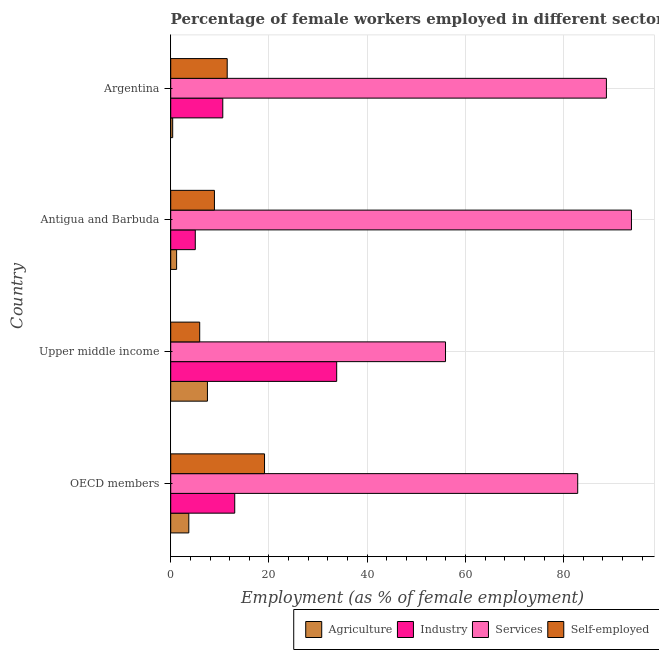How many different coloured bars are there?
Your answer should be compact. 4. How many bars are there on the 4th tick from the top?
Provide a succinct answer. 4. What is the label of the 1st group of bars from the top?
Your response must be concise. Argentina. In how many cases, is the number of bars for a given country not equal to the number of legend labels?
Your response must be concise. 0. What is the percentage of female workers in agriculture in OECD members?
Give a very brief answer. 3.68. Across all countries, what is the maximum percentage of self employed female workers?
Your response must be concise. 19.1. Across all countries, what is the minimum percentage of female workers in agriculture?
Offer a very short reply. 0.4. In which country was the percentage of self employed female workers minimum?
Make the answer very short. Upper middle income. What is the total percentage of female workers in agriculture in the graph?
Ensure brevity in your answer.  12.76. What is the difference between the percentage of female workers in agriculture in Argentina and that in OECD members?
Provide a succinct answer. -3.28. What is the difference between the percentage of self employed female workers in OECD members and the percentage of female workers in industry in Upper middle income?
Your answer should be very brief. -14.69. What is the average percentage of female workers in industry per country?
Provide a short and direct response. 15.61. What is the difference between the percentage of self employed female workers and percentage of female workers in services in Antigua and Barbuda?
Make the answer very short. -84.9. What is the ratio of the percentage of self employed female workers in Argentina to that in Upper middle income?
Offer a terse response. 1.95. Is the percentage of female workers in agriculture in Antigua and Barbuda less than that in Upper middle income?
Provide a short and direct response. Yes. Is the difference between the percentage of female workers in agriculture in Argentina and Upper middle income greater than the difference between the percentage of female workers in industry in Argentina and Upper middle income?
Make the answer very short. Yes. What is the difference between the highest and the second highest percentage of female workers in industry?
Provide a succinct answer. 20.75. What is the difference between the highest and the lowest percentage of female workers in agriculture?
Provide a succinct answer. 7.07. Is the sum of the percentage of self employed female workers in Argentina and Upper middle income greater than the maximum percentage of female workers in agriculture across all countries?
Offer a terse response. Yes. What does the 3rd bar from the top in Upper middle income represents?
Make the answer very short. Industry. What does the 1st bar from the bottom in Upper middle income represents?
Your response must be concise. Agriculture. Are all the bars in the graph horizontal?
Your response must be concise. Yes. How many countries are there in the graph?
Your response must be concise. 4. What is the difference between two consecutive major ticks on the X-axis?
Make the answer very short. 20. Does the graph contain any zero values?
Keep it short and to the point. No. Where does the legend appear in the graph?
Your answer should be compact. Bottom right. What is the title of the graph?
Offer a terse response. Percentage of female workers employed in different sectors of an economy in 2007. Does "Regional development banks" appear as one of the legend labels in the graph?
Make the answer very short. No. What is the label or title of the X-axis?
Keep it short and to the point. Employment (as % of female employment). What is the label or title of the Y-axis?
Your answer should be very brief. Country. What is the Employment (as % of female employment) in Agriculture in OECD members?
Ensure brevity in your answer.  3.68. What is the Employment (as % of female employment) of Industry in OECD members?
Provide a succinct answer. 13.03. What is the Employment (as % of female employment) in Services in OECD members?
Your answer should be very brief. 82.86. What is the Employment (as % of female employment) of Self-employed in OECD members?
Provide a succinct answer. 19.1. What is the Employment (as % of female employment) of Agriculture in Upper middle income?
Provide a succinct answer. 7.47. What is the Employment (as % of female employment) in Industry in Upper middle income?
Keep it short and to the point. 33.79. What is the Employment (as % of female employment) of Services in Upper middle income?
Provide a succinct answer. 55.94. What is the Employment (as % of female employment) of Self-employed in Upper middle income?
Provide a succinct answer. 5.9. What is the Employment (as % of female employment) of Agriculture in Antigua and Barbuda?
Provide a succinct answer. 1.2. What is the Employment (as % of female employment) in Services in Antigua and Barbuda?
Provide a short and direct response. 93.8. What is the Employment (as % of female employment) of Self-employed in Antigua and Barbuda?
Provide a short and direct response. 8.9. What is the Employment (as % of female employment) of Agriculture in Argentina?
Your answer should be very brief. 0.4. What is the Employment (as % of female employment) in Industry in Argentina?
Offer a very short reply. 10.6. What is the Employment (as % of female employment) in Services in Argentina?
Your answer should be very brief. 88.7. Across all countries, what is the maximum Employment (as % of female employment) in Agriculture?
Offer a very short reply. 7.47. Across all countries, what is the maximum Employment (as % of female employment) of Industry?
Your answer should be very brief. 33.79. Across all countries, what is the maximum Employment (as % of female employment) in Services?
Offer a terse response. 93.8. Across all countries, what is the maximum Employment (as % of female employment) of Self-employed?
Your answer should be compact. 19.1. Across all countries, what is the minimum Employment (as % of female employment) in Agriculture?
Your answer should be very brief. 0.4. Across all countries, what is the minimum Employment (as % of female employment) in Services?
Provide a succinct answer. 55.94. Across all countries, what is the minimum Employment (as % of female employment) in Self-employed?
Your answer should be very brief. 5.9. What is the total Employment (as % of female employment) in Agriculture in the graph?
Your response must be concise. 12.76. What is the total Employment (as % of female employment) of Industry in the graph?
Your answer should be compact. 62.42. What is the total Employment (as % of female employment) of Services in the graph?
Your answer should be compact. 321.3. What is the total Employment (as % of female employment) of Self-employed in the graph?
Keep it short and to the point. 45.4. What is the difference between the Employment (as % of female employment) in Agriculture in OECD members and that in Upper middle income?
Make the answer very short. -3.79. What is the difference between the Employment (as % of female employment) of Industry in OECD members and that in Upper middle income?
Make the answer very short. -20.75. What is the difference between the Employment (as % of female employment) of Services in OECD members and that in Upper middle income?
Your answer should be compact. 26.91. What is the difference between the Employment (as % of female employment) of Self-employed in OECD members and that in Upper middle income?
Provide a succinct answer. 13.2. What is the difference between the Employment (as % of female employment) of Agriculture in OECD members and that in Antigua and Barbuda?
Offer a very short reply. 2.48. What is the difference between the Employment (as % of female employment) of Industry in OECD members and that in Antigua and Barbuda?
Offer a terse response. 8.03. What is the difference between the Employment (as % of female employment) of Services in OECD members and that in Antigua and Barbuda?
Your answer should be compact. -10.94. What is the difference between the Employment (as % of female employment) of Agriculture in OECD members and that in Argentina?
Provide a short and direct response. 3.28. What is the difference between the Employment (as % of female employment) in Industry in OECD members and that in Argentina?
Your response must be concise. 2.43. What is the difference between the Employment (as % of female employment) of Services in OECD members and that in Argentina?
Your answer should be very brief. -5.84. What is the difference between the Employment (as % of female employment) in Self-employed in OECD members and that in Argentina?
Make the answer very short. 7.6. What is the difference between the Employment (as % of female employment) in Agriculture in Upper middle income and that in Antigua and Barbuda?
Offer a terse response. 6.27. What is the difference between the Employment (as % of female employment) of Industry in Upper middle income and that in Antigua and Barbuda?
Your answer should be compact. 28.79. What is the difference between the Employment (as % of female employment) in Services in Upper middle income and that in Antigua and Barbuda?
Provide a short and direct response. -37.86. What is the difference between the Employment (as % of female employment) in Agriculture in Upper middle income and that in Argentina?
Provide a succinct answer. 7.07. What is the difference between the Employment (as % of female employment) in Industry in Upper middle income and that in Argentina?
Offer a terse response. 23.19. What is the difference between the Employment (as % of female employment) of Services in Upper middle income and that in Argentina?
Offer a very short reply. -32.76. What is the difference between the Employment (as % of female employment) of Agriculture in OECD members and the Employment (as % of female employment) of Industry in Upper middle income?
Keep it short and to the point. -30.11. What is the difference between the Employment (as % of female employment) of Agriculture in OECD members and the Employment (as % of female employment) of Services in Upper middle income?
Your response must be concise. -52.26. What is the difference between the Employment (as % of female employment) of Agriculture in OECD members and the Employment (as % of female employment) of Self-employed in Upper middle income?
Your response must be concise. -2.22. What is the difference between the Employment (as % of female employment) of Industry in OECD members and the Employment (as % of female employment) of Services in Upper middle income?
Provide a short and direct response. -42.91. What is the difference between the Employment (as % of female employment) in Industry in OECD members and the Employment (as % of female employment) in Self-employed in Upper middle income?
Your answer should be compact. 7.13. What is the difference between the Employment (as % of female employment) of Services in OECD members and the Employment (as % of female employment) of Self-employed in Upper middle income?
Provide a short and direct response. 76.96. What is the difference between the Employment (as % of female employment) of Agriculture in OECD members and the Employment (as % of female employment) of Industry in Antigua and Barbuda?
Keep it short and to the point. -1.32. What is the difference between the Employment (as % of female employment) in Agriculture in OECD members and the Employment (as % of female employment) in Services in Antigua and Barbuda?
Your answer should be very brief. -90.12. What is the difference between the Employment (as % of female employment) in Agriculture in OECD members and the Employment (as % of female employment) in Self-employed in Antigua and Barbuda?
Your answer should be compact. -5.22. What is the difference between the Employment (as % of female employment) of Industry in OECD members and the Employment (as % of female employment) of Services in Antigua and Barbuda?
Ensure brevity in your answer.  -80.77. What is the difference between the Employment (as % of female employment) in Industry in OECD members and the Employment (as % of female employment) in Self-employed in Antigua and Barbuda?
Give a very brief answer. 4.13. What is the difference between the Employment (as % of female employment) in Services in OECD members and the Employment (as % of female employment) in Self-employed in Antigua and Barbuda?
Keep it short and to the point. 73.96. What is the difference between the Employment (as % of female employment) in Agriculture in OECD members and the Employment (as % of female employment) in Industry in Argentina?
Provide a succinct answer. -6.92. What is the difference between the Employment (as % of female employment) in Agriculture in OECD members and the Employment (as % of female employment) in Services in Argentina?
Your answer should be compact. -85.02. What is the difference between the Employment (as % of female employment) in Agriculture in OECD members and the Employment (as % of female employment) in Self-employed in Argentina?
Offer a terse response. -7.82. What is the difference between the Employment (as % of female employment) of Industry in OECD members and the Employment (as % of female employment) of Services in Argentina?
Make the answer very short. -75.67. What is the difference between the Employment (as % of female employment) in Industry in OECD members and the Employment (as % of female employment) in Self-employed in Argentina?
Your response must be concise. 1.53. What is the difference between the Employment (as % of female employment) in Services in OECD members and the Employment (as % of female employment) in Self-employed in Argentina?
Your answer should be compact. 71.36. What is the difference between the Employment (as % of female employment) of Agriculture in Upper middle income and the Employment (as % of female employment) of Industry in Antigua and Barbuda?
Keep it short and to the point. 2.47. What is the difference between the Employment (as % of female employment) of Agriculture in Upper middle income and the Employment (as % of female employment) of Services in Antigua and Barbuda?
Provide a short and direct response. -86.33. What is the difference between the Employment (as % of female employment) in Agriculture in Upper middle income and the Employment (as % of female employment) in Self-employed in Antigua and Barbuda?
Your answer should be very brief. -1.43. What is the difference between the Employment (as % of female employment) in Industry in Upper middle income and the Employment (as % of female employment) in Services in Antigua and Barbuda?
Keep it short and to the point. -60.01. What is the difference between the Employment (as % of female employment) of Industry in Upper middle income and the Employment (as % of female employment) of Self-employed in Antigua and Barbuda?
Offer a very short reply. 24.89. What is the difference between the Employment (as % of female employment) in Services in Upper middle income and the Employment (as % of female employment) in Self-employed in Antigua and Barbuda?
Offer a terse response. 47.04. What is the difference between the Employment (as % of female employment) in Agriculture in Upper middle income and the Employment (as % of female employment) in Industry in Argentina?
Give a very brief answer. -3.13. What is the difference between the Employment (as % of female employment) of Agriculture in Upper middle income and the Employment (as % of female employment) of Services in Argentina?
Provide a succinct answer. -81.23. What is the difference between the Employment (as % of female employment) in Agriculture in Upper middle income and the Employment (as % of female employment) in Self-employed in Argentina?
Provide a short and direct response. -4.03. What is the difference between the Employment (as % of female employment) in Industry in Upper middle income and the Employment (as % of female employment) in Services in Argentina?
Your answer should be very brief. -54.91. What is the difference between the Employment (as % of female employment) in Industry in Upper middle income and the Employment (as % of female employment) in Self-employed in Argentina?
Your answer should be very brief. 22.29. What is the difference between the Employment (as % of female employment) in Services in Upper middle income and the Employment (as % of female employment) in Self-employed in Argentina?
Ensure brevity in your answer.  44.44. What is the difference between the Employment (as % of female employment) of Agriculture in Antigua and Barbuda and the Employment (as % of female employment) of Services in Argentina?
Your answer should be compact. -87.5. What is the difference between the Employment (as % of female employment) of Industry in Antigua and Barbuda and the Employment (as % of female employment) of Services in Argentina?
Keep it short and to the point. -83.7. What is the difference between the Employment (as % of female employment) in Industry in Antigua and Barbuda and the Employment (as % of female employment) in Self-employed in Argentina?
Give a very brief answer. -6.5. What is the difference between the Employment (as % of female employment) in Services in Antigua and Barbuda and the Employment (as % of female employment) in Self-employed in Argentina?
Provide a short and direct response. 82.3. What is the average Employment (as % of female employment) of Agriculture per country?
Keep it short and to the point. 3.19. What is the average Employment (as % of female employment) in Industry per country?
Your answer should be compact. 15.61. What is the average Employment (as % of female employment) in Services per country?
Offer a very short reply. 80.32. What is the average Employment (as % of female employment) in Self-employed per country?
Offer a terse response. 11.35. What is the difference between the Employment (as % of female employment) in Agriculture and Employment (as % of female employment) in Industry in OECD members?
Give a very brief answer. -9.35. What is the difference between the Employment (as % of female employment) of Agriculture and Employment (as % of female employment) of Services in OECD members?
Your response must be concise. -79.17. What is the difference between the Employment (as % of female employment) of Agriculture and Employment (as % of female employment) of Self-employed in OECD members?
Your answer should be very brief. -15.42. What is the difference between the Employment (as % of female employment) of Industry and Employment (as % of female employment) of Services in OECD members?
Provide a short and direct response. -69.82. What is the difference between the Employment (as % of female employment) in Industry and Employment (as % of female employment) in Self-employed in OECD members?
Your answer should be very brief. -6.07. What is the difference between the Employment (as % of female employment) of Services and Employment (as % of female employment) of Self-employed in OECD members?
Give a very brief answer. 63.76. What is the difference between the Employment (as % of female employment) of Agriculture and Employment (as % of female employment) of Industry in Upper middle income?
Your answer should be compact. -26.31. What is the difference between the Employment (as % of female employment) of Agriculture and Employment (as % of female employment) of Services in Upper middle income?
Give a very brief answer. -48.47. What is the difference between the Employment (as % of female employment) in Agriculture and Employment (as % of female employment) in Self-employed in Upper middle income?
Ensure brevity in your answer.  1.57. What is the difference between the Employment (as % of female employment) in Industry and Employment (as % of female employment) in Services in Upper middle income?
Offer a terse response. -22.16. What is the difference between the Employment (as % of female employment) of Industry and Employment (as % of female employment) of Self-employed in Upper middle income?
Make the answer very short. 27.89. What is the difference between the Employment (as % of female employment) in Services and Employment (as % of female employment) in Self-employed in Upper middle income?
Your answer should be compact. 50.04. What is the difference between the Employment (as % of female employment) in Agriculture and Employment (as % of female employment) in Industry in Antigua and Barbuda?
Offer a very short reply. -3.8. What is the difference between the Employment (as % of female employment) of Agriculture and Employment (as % of female employment) of Services in Antigua and Barbuda?
Offer a terse response. -92.6. What is the difference between the Employment (as % of female employment) of Agriculture and Employment (as % of female employment) of Self-employed in Antigua and Barbuda?
Provide a short and direct response. -7.7. What is the difference between the Employment (as % of female employment) of Industry and Employment (as % of female employment) of Services in Antigua and Barbuda?
Provide a succinct answer. -88.8. What is the difference between the Employment (as % of female employment) in Services and Employment (as % of female employment) in Self-employed in Antigua and Barbuda?
Offer a very short reply. 84.9. What is the difference between the Employment (as % of female employment) of Agriculture and Employment (as % of female employment) of Industry in Argentina?
Offer a very short reply. -10.2. What is the difference between the Employment (as % of female employment) of Agriculture and Employment (as % of female employment) of Services in Argentina?
Your response must be concise. -88.3. What is the difference between the Employment (as % of female employment) in Agriculture and Employment (as % of female employment) in Self-employed in Argentina?
Make the answer very short. -11.1. What is the difference between the Employment (as % of female employment) in Industry and Employment (as % of female employment) in Services in Argentina?
Give a very brief answer. -78.1. What is the difference between the Employment (as % of female employment) in Services and Employment (as % of female employment) in Self-employed in Argentina?
Your answer should be very brief. 77.2. What is the ratio of the Employment (as % of female employment) of Agriculture in OECD members to that in Upper middle income?
Your response must be concise. 0.49. What is the ratio of the Employment (as % of female employment) in Industry in OECD members to that in Upper middle income?
Ensure brevity in your answer.  0.39. What is the ratio of the Employment (as % of female employment) of Services in OECD members to that in Upper middle income?
Offer a terse response. 1.48. What is the ratio of the Employment (as % of female employment) of Self-employed in OECD members to that in Upper middle income?
Give a very brief answer. 3.24. What is the ratio of the Employment (as % of female employment) in Agriculture in OECD members to that in Antigua and Barbuda?
Your answer should be compact. 3.07. What is the ratio of the Employment (as % of female employment) of Industry in OECD members to that in Antigua and Barbuda?
Offer a terse response. 2.61. What is the ratio of the Employment (as % of female employment) of Services in OECD members to that in Antigua and Barbuda?
Keep it short and to the point. 0.88. What is the ratio of the Employment (as % of female employment) of Self-employed in OECD members to that in Antigua and Barbuda?
Keep it short and to the point. 2.15. What is the ratio of the Employment (as % of female employment) of Agriculture in OECD members to that in Argentina?
Keep it short and to the point. 9.21. What is the ratio of the Employment (as % of female employment) in Industry in OECD members to that in Argentina?
Ensure brevity in your answer.  1.23. What is the ratio of the Employment (as % of female employment) in Services in OECD members to that in Argentina?
Keep it short and to the point. 0.93. What is the ratio of the Employment (as % of female employment) of Self-employed in OECD members to that in Argentina?
Your response must be concise. 1.66. What is the ratio of the Employment (as % of female employment) in Agriculture in Upper middle income to that in Antigua and Barbuda?
Provide a succinct answer. 6.23. What is the ratio of the Employment (as % of female employment) in Industry in Upper middle income to that in Antigua and Barbuda?
Make the answer very short. 6.76. What is the ratio of the Employment (as % of female employment) of Services in Upper middle income to that in Antigua and Barbuda?
Offer a very short reply. 0.6. What is the ratio of the Employment (as % of female employment) of Self-employed in Upper middle income to that in Antigua and Barbuda?
Your response must be concise. 0.66. What is the ratio of the Employment (as % of female employment) in Agriculture in Upper middle income to that in Argentina?
Provide a succinct answer. 18.69. What is the ratio of the Employment (as % of female employment) of Industry in Upper middle income to that in Argentina?
Make the answer very short. 3.19. What is the ratio of the Employment (as % of female employment) in Services in Upper middle income to that in Argentina?
Ensure brevity in your answer.  0.63. What is the ratio of the Employment (as % of female employment) in Self-employed in Upper middle income to that in Argentina?
Your response must be concise. 0.51. What is the ratio of the Employment (as % of female employment) of Agriculture in Antigua and Barbuda to that in Argentina?
Provide a short and direct response. 3. What is the ratio of the Employment (as % of female employment) of Industry in Antigua and Barbuda to that in Argentina?
Your answer should be very brief. 0.47. What is the ratio of the Employment (as % of female employment) of Services in Antigua and Barbuda to that in Argentina?
Provide a short and direct response. 1.06. What is the ratio of the Employment (as % of female employment) of Self-employed in Antigua and Barbuda to that in Argentina?
Your response must be concise. 0.77. What is the difference between the highest and the second highest Employment (as % of female employment) of Agriculture?
Keep it short and to the point. 3.79. What is the difference between the highest and the second highest Employment (as % of female employment) in Industry?
Make the answer very short. 20.75. What is the difference between the highest and the second highest Employment (as % of female employment) in Services?
Ensure brevity in your answer.  5.1. What is the difference between the highest and the second highest Employment (as % of female employment) of Self-employed?
Ensure brevity in your answer.  7.6. What is the difference between the highest and the lowest Employment (as % of female employment) of Agriculture?
Provide a short and direct response. 7.07. What is the difference between the highest and the lowest Employment (as % of female employment) of Industry?
Offer a very short reply. 28.79. What is the difference between the highest and the lowest Employment (as % of female employment) of Services?
Keep it short and to the point. 37.86. 